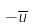<formula> <loc_0><loc_0><loc_500><loc_500>- \overline { u }</formula> 